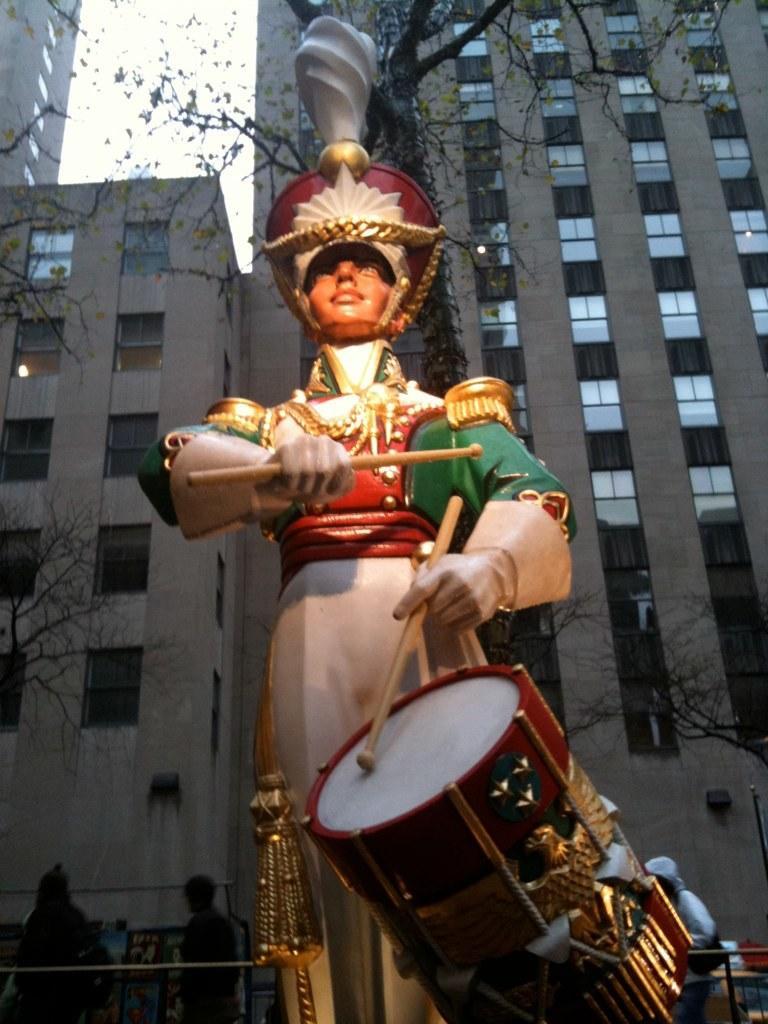Please provide a concise description of this image. In this picture we can see a statue, in the background we can find few people, trees and buildings. 